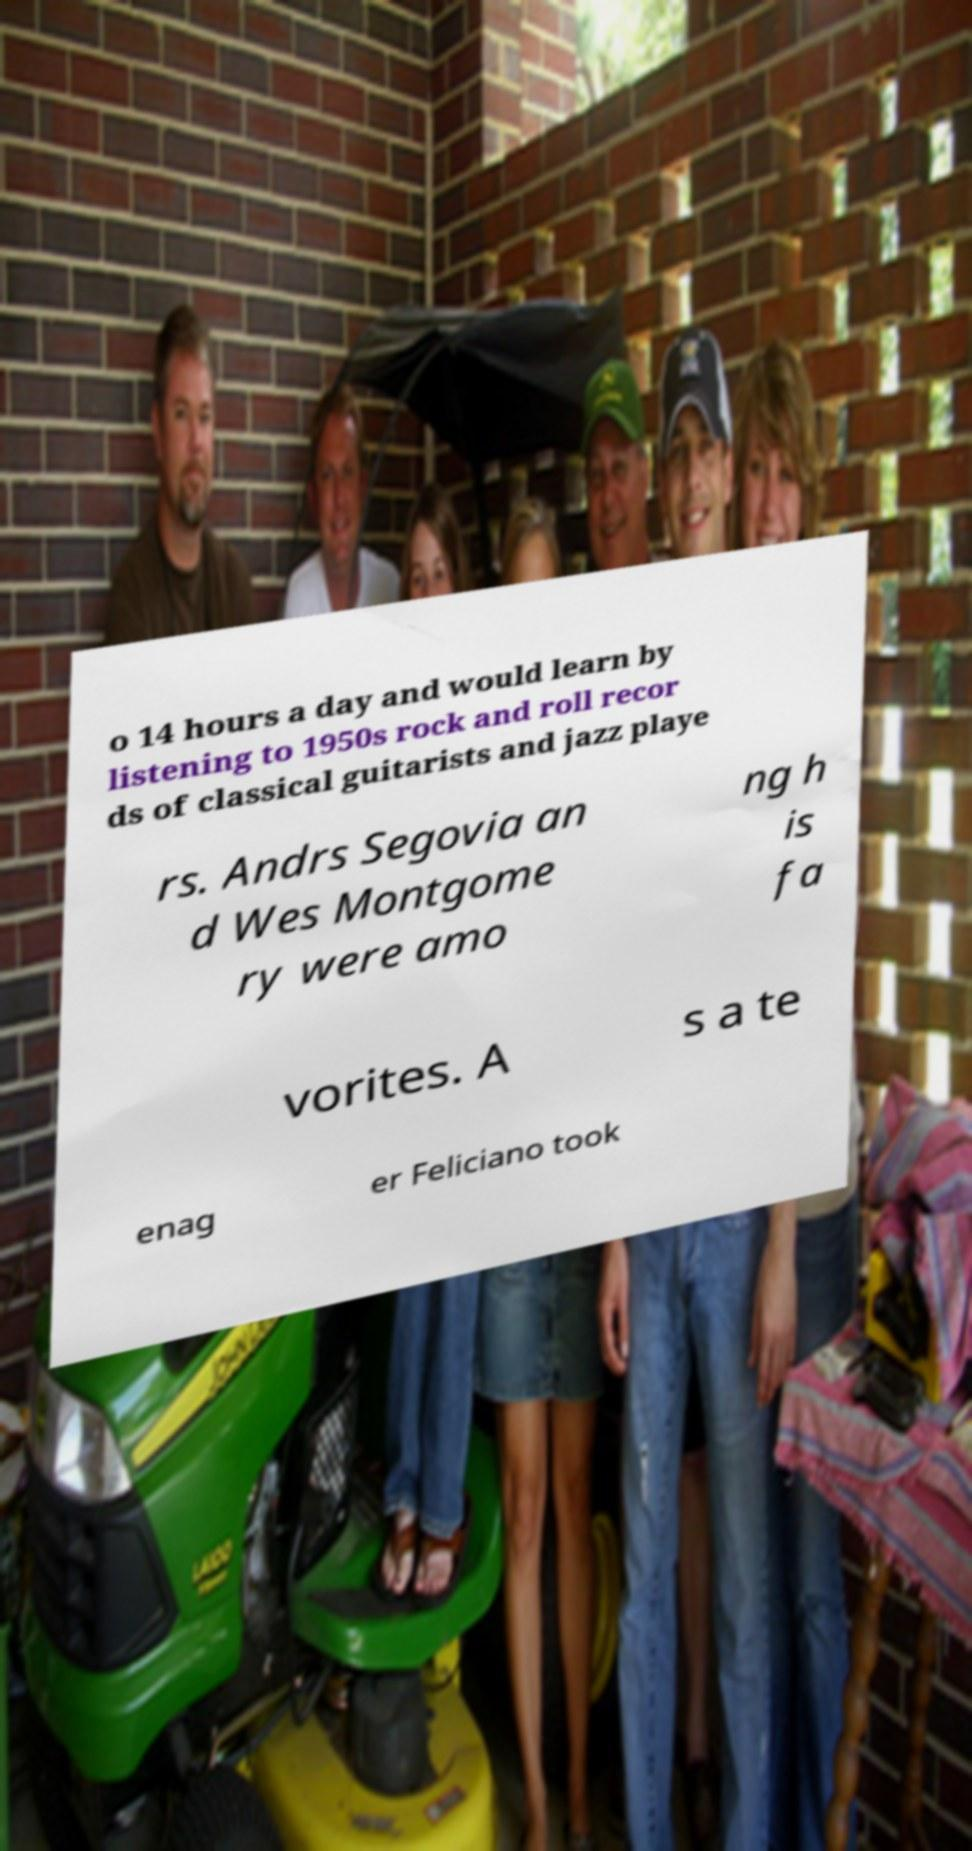There's text embedded in this image that I need extracted. Can you transcribe it verbatim? o 14 hours a day and would learn by listening to 1950s rock and roll recor ds of classical guitarists and jazz playe rs. Andrs Segovia an d Wes Montgome ry were amo ng h is fa vorites. A s a te enag er Feliciano took 